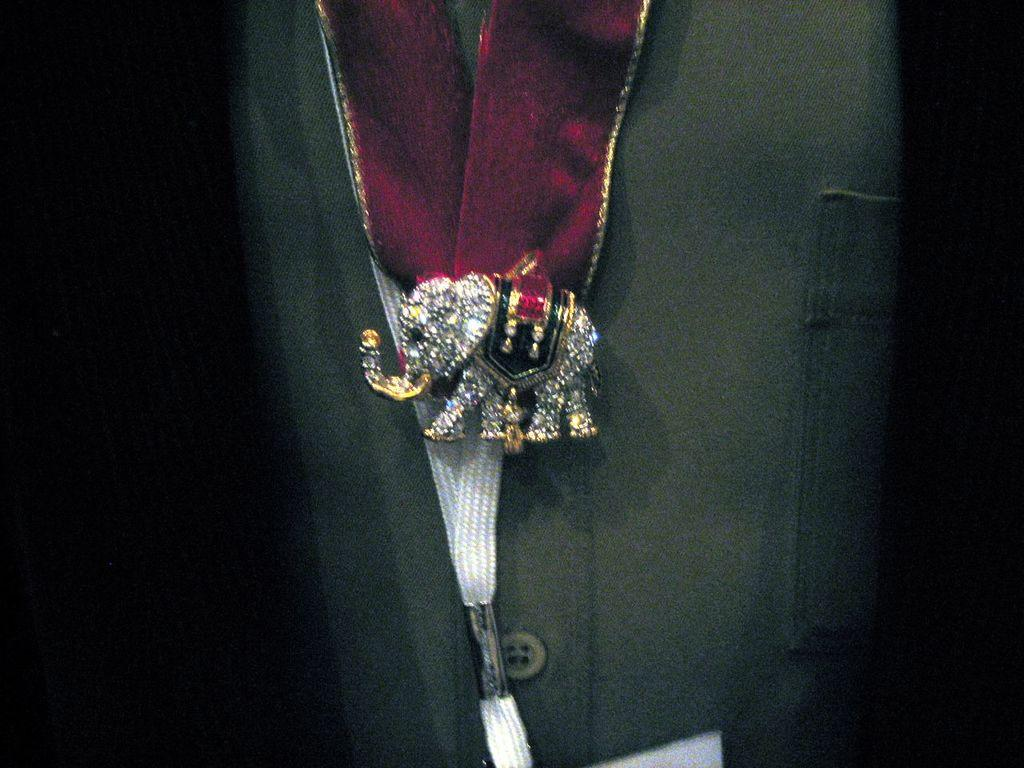What type of animal is depicted in the image? There is a small elephant in the image. Is the small elephant a real animal or a representation? The small elephant is a toy. What is attached to the small elephant in the image? Something is tied to the small elephant. What type of brake system is installed on the small elephant in the image? There is no brake system present on the small elephant in the image, as it is a toy and not a vehicle. 